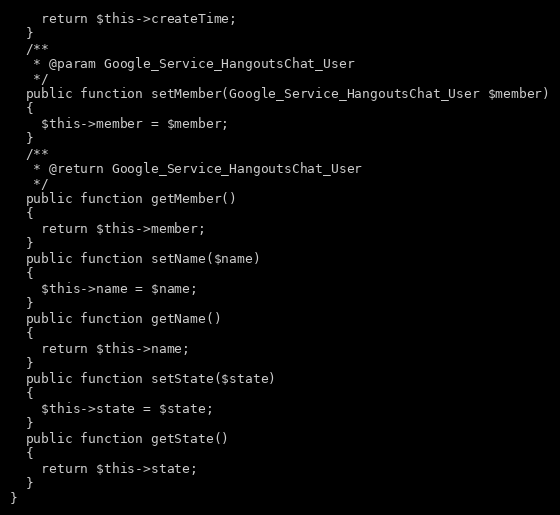Convert code to text. <code><loc_0><loc_0><loc_500><loc_500><_PHP_>    return $this->createTime;
  }
  /**
   * @param Google_Service_HangoutsChat_User
   */
  public function setMember(Google_Service_HangoutsChat_User $member)
  {
    $this->member = $member;
  }
  /**
   * @return Google_Service_HangoutsChat_User
   */
  public function getMember()
  {
    return $this->member;
  }
  public function setName($name)
  {
    $this->name = $name;
  }
  public function getName()
  {
    return $this->name;
  }
  public function setState($state)
  {
    $this->state = $state;
  }
  public function getState()
  {
    return $this->state;
  }
}
</code> 